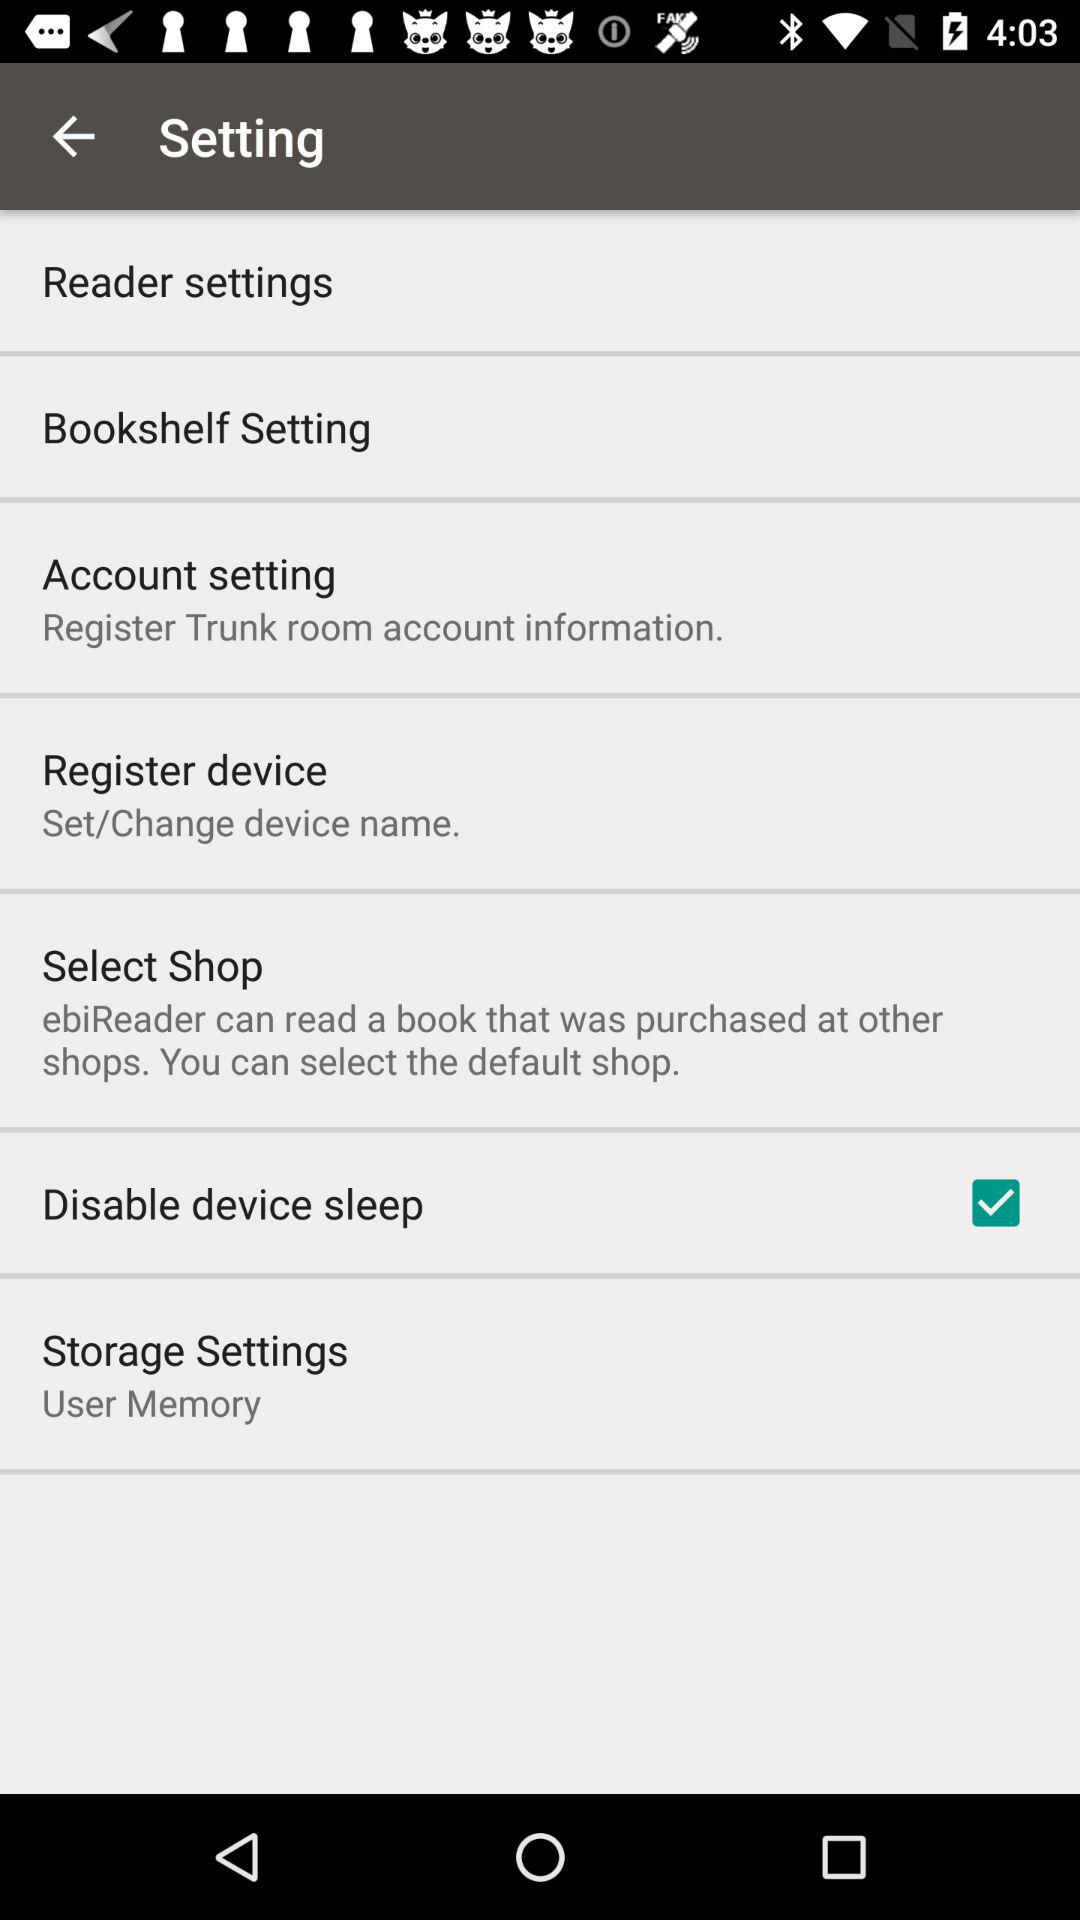What's the setting for "Storage Settings"? The setting for "Storage Settings" is "User Memory". 